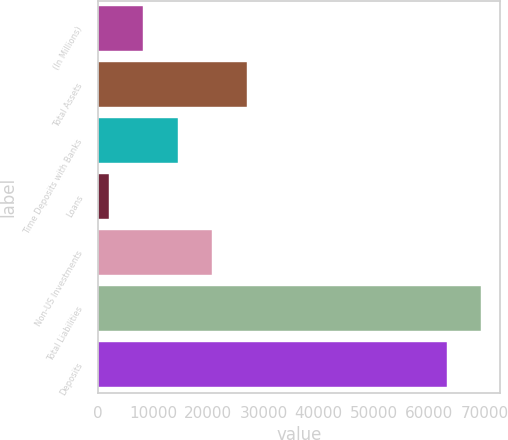Convert chart to OTSL. <chart><loc_0><loc_0><loc_500><loc_500><bar_chart><fcel>(In Millions)<fcel>Total Assets<fcel>Time Deposits with Banks<fcel>Loans<fcel>Non-US Investments<fcel>Total Liabilities<fcel>Deposits<nl><fcel>8240.05<fcel>26915.8<fcel>14465.3<fcel>2014.8<fcel>20690.5<fcel>69408.8<fcel>63183.5<nl></chart> 